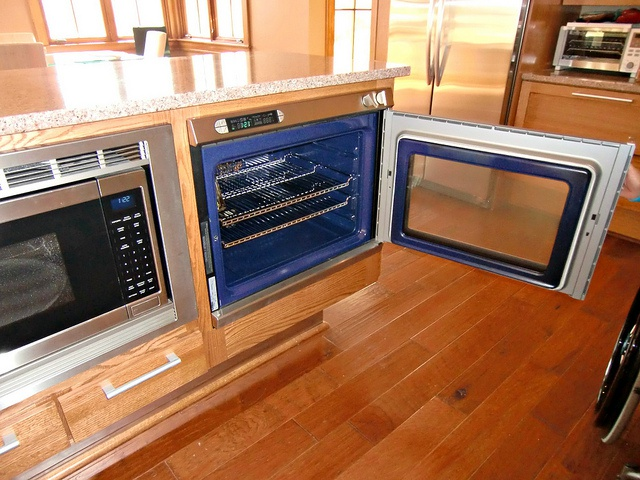Describe the objects in this image and their specific colors. I can see oven in tan, navy, black, brown, and gray tones, microwave in tan, black, gray, and darkgray tones, dining table in tan and white tones, refrigerator in tan, khaki, and lightyellow tones, and oven in tan, black, and gray tones in this image. 